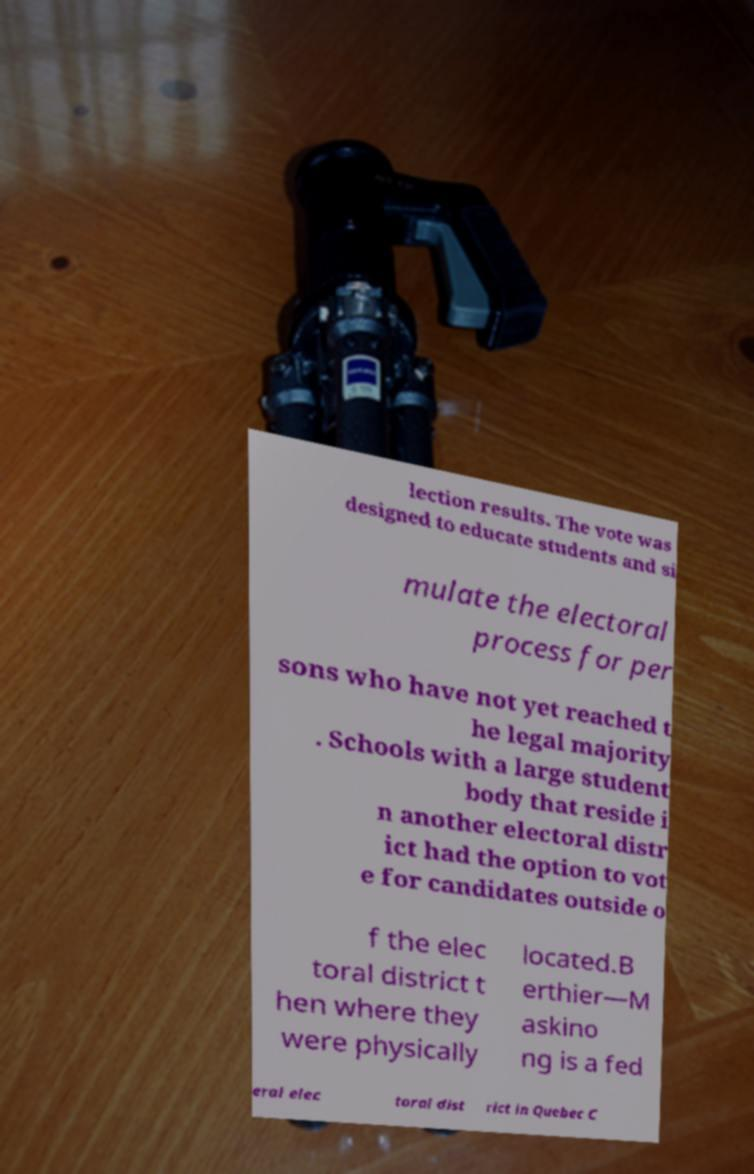I need the written content from this picture converted into text. Can you do that? lection results. The vote was designed to educate students and si mulate the electoral process for per sons who have not yet reached t he legal majority . Schools with a large student body that reside i n another electoral distr ict had the option to vot e for candidates outside o f the elec toral district t hen where they were physically located.B erthier—M askino ng is a fed eral elec toral dist rict in Quebec C 